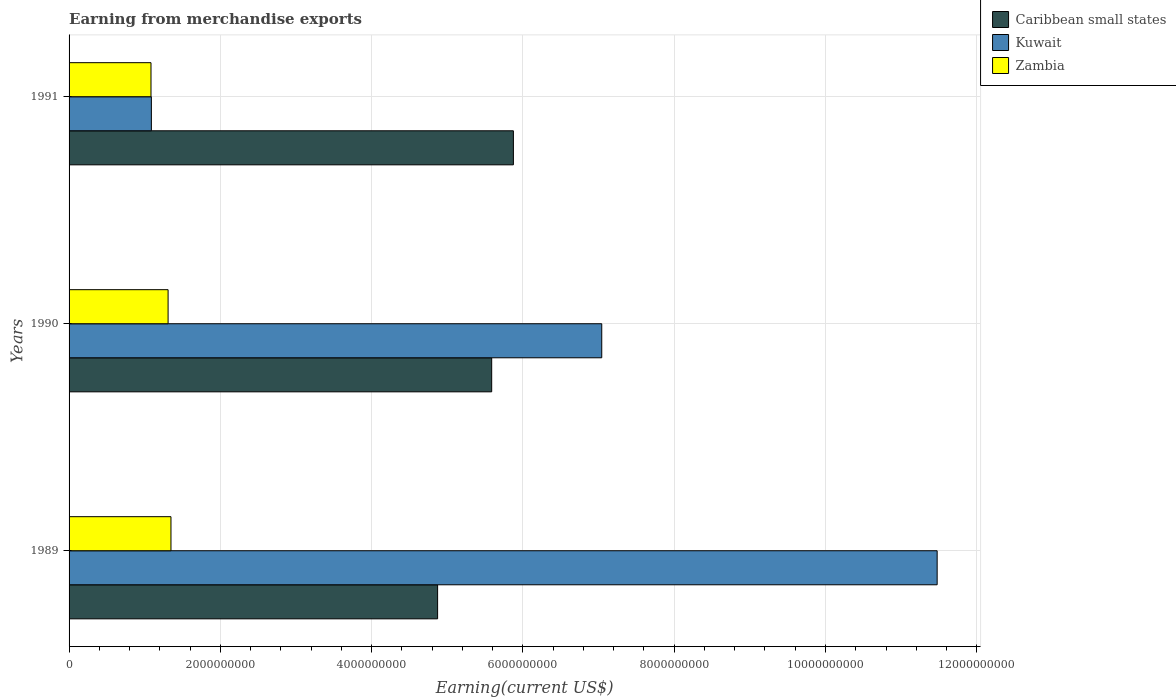How many groups of bars are there?
Give a very brief answer. 3. Are the number of bars per tick equal to the number of legend labels?
Keep it short and to the point. Yes. How many bars are there on the 2nd tick from the top?
Offer a very short reply. 3. How many bars are there on the 2nd tick from the bottom?
Provide a succinct answer. 3. What is the label of the 1st group of bars from the top?
Your answer should be very brief. 1991. In how many cases, is the number of bars for a given year not equal to the number of legend labels?
Give a very brief answer. 0. What is the amount earned from merchandise exports in Kuwait in 1990?
Ensure brevity in your answer.  7.04e+09. Across all years, what is the maximum amount earned from merchandise exports in Zambia?
Keep it short and to the point. 1.35e+09. Across all years, what is the minimum amount earned from merchandise exports in Zambia?
Ensure brevity in your answer.  1.08e+09. What is the total amount earned from merchandise exports in Kuwait in the graph?
Your answer should be compact. 1.96e+1. What is the difference between the amount earned from merchandise exports in Caribbean small states in 1989 and that in 1990?
Offer a very short reply. -7.15e+08. What is the difference between the amount earned from merchandise exports in Caribbean small states in 1991 and the amount earned from merchandise exports in Zambia in 1989?
Keep it short and to the point. 4.53e+09. What is the average amount earned from merchandise exports in Kuwait per year?
Your answer should be compact. 6.54e+09. In the year 1989, what is the difference between the amount earned from merchandise exports in Kuwait and amount earned from merchandise exports in Caribbean small states?
Give a very brief answer. 6.60e+09. In how many years, is the amount earned from merchandise exports in Kuwait greater than 1200000000 US$?
Provide a short and direct response. 2. What is the ratio of the amount earned from merchandise exports in Caribbean small states in 1989 to that in 1990?
Provide a short and direct response. 0.87. Is the amount earned from merchandise exports in Zambia in 1990 less than that in 1991?
Keep it short and to the point. No. What is the difference between the highest and the second highest amount earned from merchandise exports in Kuwait?
Your answer should be very brief. 4.43e+09. What is the difference between the highest and the lowest amount earned from merchandise exports in Caribbean small states?
Your response must be concise. 1.00e+09. What does the 1st bar from the top in 1990 represents?
Ensure brevity in your answer.  Zambia. What does the 1st bar from the bottom in 1990 represents?
Your response must be concise. Caribbean small states. Is it the case that in every year, the sum of the amount earned from merchandise exports in Kuwait and amount earned from merchandise exports in Caribbean small states is greater than the amount earned from merchandise exports in Zambia?
Give a very brief answer. Yes. How many bars are there?
Keep it short and to the point. 9. How many years are there in the graph?
Provide a succinct answer. 3. Does the graph contain grids?
Keep it short and to the point. Yes. Where does the legend appear in the graph?
Offer a very short reply. Top right. How many legend labels are there?
Provide a short and direct response. 3. How are the legend labels stacked?
Your answer should be compact. Vertical. What is the title of the graph?
Offer a terse response. Earning from merchandise exports. What is the label or title of the X-axis?
Your answer should be compact. Earning(current US$). What is the label or title of the Y-axis?
Your response must be concise. Years. What is the Earning(current US$) in Caribbean small states in 1989?
Your response must be concise. 4.87e+09. What is the Earning(current US$) of Kuwait in 1989?
Your response must be concise. 1.15e+1. What is the Earning(current US$) of Zambia in 1989?
Ensure brevity in your answer.  1.35e+09. What is the Earning(current US$) in Caribbean small states in 1990?
Offer a very short reply. 5.59e+09. What is the Earning(current US$) in Kuwait in 1990?
Make the answer very short. 7.04e+09. What is the Earning(current US$) of Zambia in 1990?
Ensure brevity in your answer.  1.31e+09. What is the Earning(current US$) in Caribbean small states in 1991?
Your answer should be compact. 5.87e+09. What is the Earning(current US$) in Kuwait in 1991?
Make the answer very short. 1.09e+09. What is the Earning(current US$) in Zambia in 1991?
Offer a very short reply. 1.08e+09. Across all years, what is the maximum Earning(current US$) of Caribbean small states?
Give a very brief answer. 5.87e+09. Across all years, what is the maximum Earning(current US$) of Kuwait?
Provide a short and direct response. 1.15e+1. Across all years, what is the maximum Earning(current US$) of Zambia?
Ensure brevity in your answer.  1.35e+09. Across all years, what is the minimum Earning(current US$) in Caribbean small states?
Provide a succinct answer. 4.87e+09. Across all years, what is the minimum Earning(current US$) of Kuwait?
Provide a succinct answer. 1.09e+09. Across all years, what is the minimum Earning(current US$) of Zambia?
Keep it short and to the point. 1.08e+09. What is the total Earning(current US$) of Caribbean small states in the graph?
Give a very brief answer. 1.63e+1. What is the total Earning(current US$) of Kuwait in the graph?
Your response must be concise. 1.96e+1. What is the total Earning(current US$) in Zambia in the graph?
Your answer should be very brief. 3.74e+09. What is the difference between the Earning(current US$) in Caribbean small states in 1989 and that in 1990?
Your answer should be compact. -7.15e+08. What is the difference between the Earning(current US$) in Kuwait in 1989 and that in 1990?
Your answer should be compact. 4.43e+09. What is the difference between the Earning(current US$) of Zambia in 1989 and that in 1990?
Your answer should be compact. 3.80e+07. What is the difference between the Earning(current US$) in Caribbean small states in 1989 and that in 1991?
Give a very brief answer. -1.00e+09. What is the difference between the Earning(current US$) of Kuwait in 1989 and that in 1991?
Ensure brevity in your answer.  1.04e+1. What is the difference between the Earning(current US$) of Zambia in 1989 and that in 1991?
Provide a succinct answer. 2.64e+08. What is the difference between the Earning(current US$) in Caribbean small states in 1990 and that in 1991?
Provide a short and direct response. -2.87e+08. What is the difference between the Earning(current US$) in Kuwait in 1990 and that in 1991?
Provide a short and direct response. 5.95e+09. What is the difference between the Earning(current US$) of Zambia in 1990 and that in 1991?
Your response must be concise. 2.26e+08. What is the difference between the Earning(current US$) of Caribbean small states in 1989 and the Earning(current US$) of Kuwait in 1990?
Your response must be concise. -2.17e+09. What is the difference between the Earning(current US$) in Caribbean small states in 1989 and the Earning(current US$) in Zambia in 1990?
Your response must be concise. 3.56e+09. What is the difference between the Earning(current US$) of Kuwait in 1989 and the Earning(current US$) of Zambia in 1990?
Offer a very short reply. 1.02e+1. What is the difference between the Earning(current US$) in Caribbean small states in 1989 and the Earning(current US$) in Kuwait in 1991?
Provide a short and direct response. 3.78e+09. What is the difference between the Earning(current US$) of Caribbean small states in 1989 and the Earning(current US$) of Zambia in 1991?
Your answer should be compact. 3.79e+09. What is the difference between the Earning(current US$) of Kuwait in 1989 and the Earning(current US$) of Zambia in 1991?
Offer a very short reply. 1.04e+1. What is the difference between the Earning(current US$) of Caribbean small states in 1990 and the Earning(current US$) of Kuwait in 1991?
Your response must be concise. 4.50e+09. What is the difference between the Earning(current US$) in Caribbean small states in 1990 and the Earning(current US$) in Zambia in 1991?
Your response must be concise. 4.50e+09. What is the difference between the Earning(current US$) of Kuwait in 1990 and the Earning(current US$) of Zambia in 1991?
Give a very brief answer. 5.96e+09. What is the average Earning(current US$) in Caribbean small states per year?
Your answer should be very brief. 5.44e+09. What is the average Earning(current US$) of Kuwait per year?
Keep it short and to the point. 6.54e+09. What is the average Earning(current US$) of Zambia per year?
Your response must be concise. 1.25e+09. In the year 1989, what is the difference between the Earning(current US$) of Caribbean small states and Earning(current US$) of Kuwait?
Make the answer very short. -6.60e+09. In the year 1989, what is the difference between the Earning(current US$) of Caribbean small states and Earning(current US$) of Zambia?
Provide a short and direct response. 3.52e+09. In the year 1989, what is the difference between the Earning(current US$) of Kuwait and Earning(current US$) of Zambia?
Your response must be concise. 1.01e+1. In the year 1990, what is the difference between the Earning(current US$) in Caribbean small states and Earning(current US$) in Kuwait?
Your answer should be compact. -1.46e+09. In the year 1990, what is the difference between the Earning(current US$) in Caribbean small states and Earning(current US$) in Zambia?
Offer a terse response. 4.28e+09. In the year 1990, what is the difference between the Earning(current US$) of Kuwait and Earning(current US$) of Zambia?
Ensure brevity in your answer.  5.73e+09. In the year 1991, what is the difference between the Earning(current US$) of Caribbean small states and Earning(current US$) of Kuwait?
Your answer should be compact. 4.79e+09. In the year 1991, what is the difference between the Earning(current US$) of Caribbean small states and Earning(current US$) of Zambia?
Your answer should be compact. 4.79e+09. In the year 1991, what is the difference between the Earning(current US$) in Kuwait and Earning(current US$) in Zambia?
Provide a short and direct response. 5.00e+06. What is the ratio of the Earning(current US$) of Caribbean small states in 1989 to that in 1990?
Your answer should be very brief. 0.87. What is the ratio of the Earning(current US$) in Kuwait in 1989 to that in 1990?
Ensure brevity in your answer.  1.63. What is the ratio of the Earning(current US$) of Zambia in 1989 to that in 1990?
Give a very brief answer. 1.03. What is the ratio of the Earning(current US$) of Caribbean small states in 1989 to that in 1991?
Offer a terse response. 0.83. What is the ratio of the Earning(current US$) of Kuwait in 1989 to that in 1991?
Provide a short and direct response. 10.55. What is the ratio of the Earning(current US$) in Zambia in 1989 to that in 1991?
Ensure brevity in your answer.  1.24. What is the ratio of the Earning(current US$) of Caribbean small states in 1990 to that in 1991?
Your response must be concise. 0.95. What is the ratio of the Earning(current US$) in Kuwait in 1990 to that in 1991?
Keep it short and to the point. 6.47. What is the ratio of the Earning(current US$) in Zambia in 1990 to that in 1991?
Make the answer very short. 1.21. What is the difference between the highest and the second highest Earning(current US$) of Caribbean small states?
Offer a terse response. 2.87e+08. What is the difference between the highest and the second highest Earning(current US$) of Kuwait?
Provide a succinct answer. 4.43e+09. What is the difference between the highest and the second highest Earning(current US$) in Zambia?
Your response must be concise. 3.80e+07. What is the difference between the highest and the lowest Earning(current US$) in Caribbean small states?
Offer a very short reply. 1.00e+09. What is the difference between the highest and the lowest Earning(current US$) in Kuwait?
Provide a short and direct response. 1.04e+1. What is the difference between the highest and the lowest Earning(current US$) of Zambia?
Your answer should be compact. 2.64e+08. 